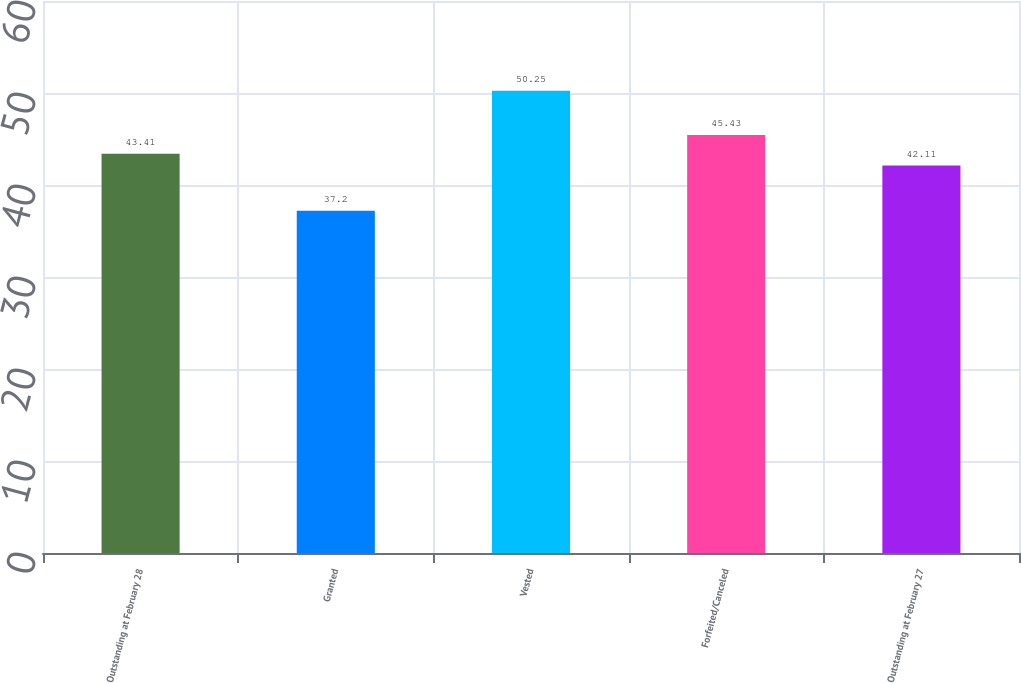Convert chart. <chart><loc_0><loc_0><loc_500><loc_500><bar_chart><fcel>Outstanding at February 28<fcel>Granted<fcel>Vested<fcel>Forfeited/Canceled<fcel>Outstanding at February 27<nl><fcel>43.41<fcel>37.2<fcel>50.25<fcel>45.43<fcel>42.11<nl></chart> 